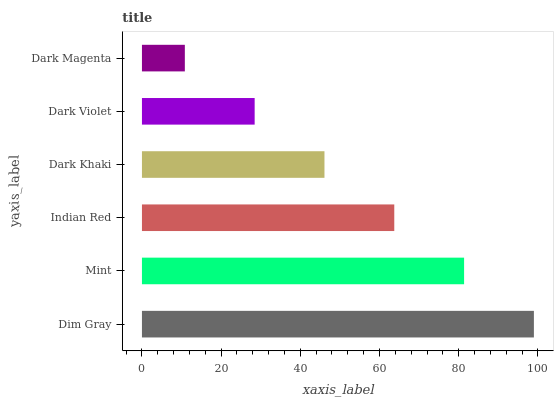Is Dark Magenta the minimum?
Answer yes or no. Yes. Is Dim Gray the maximum?
Answer yes or no. Yes. Is Mint the minimum?
Answer yes or no. No. Is Mint the maximum?
Answer yes or no. No. Is Dim Gray greater than Mint?
Answer yes or no. Yes. Is Mint less than Dim Gray?
Answer yes or no. Yes. Is Mint greater than Dim Gray?
Answer yes or no. No. Is Dim Gray less than Mint?
Answer yes or no. No. Is Indian Red the high median?
Answer yes or no. Yes. Is Dark Khaki the low median?
Answer yes or no. Yes. Is Dim Gray the high median?
Answer yes or no. No. Is Mint the low median?
Answer yes or no. No. 